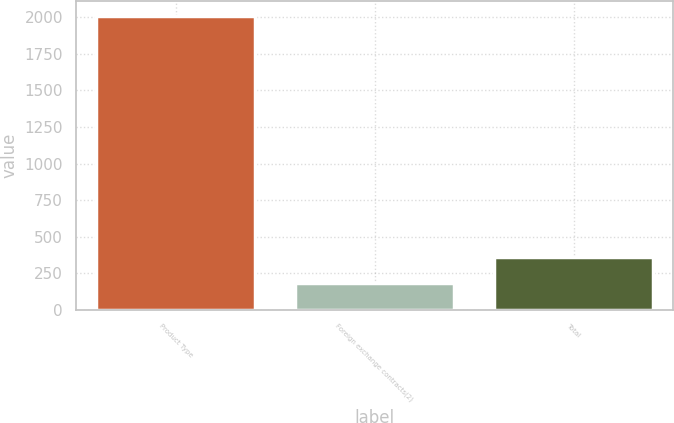<chart> <loc_0><loc_0><loc_500><loc_500><bar_chart><fcel>Product Type<fcel>Foreign exchange contracts(2)<fcel>Total<nl><fcel>2011<fcel>180<fcel>363.1<nl></chart> 